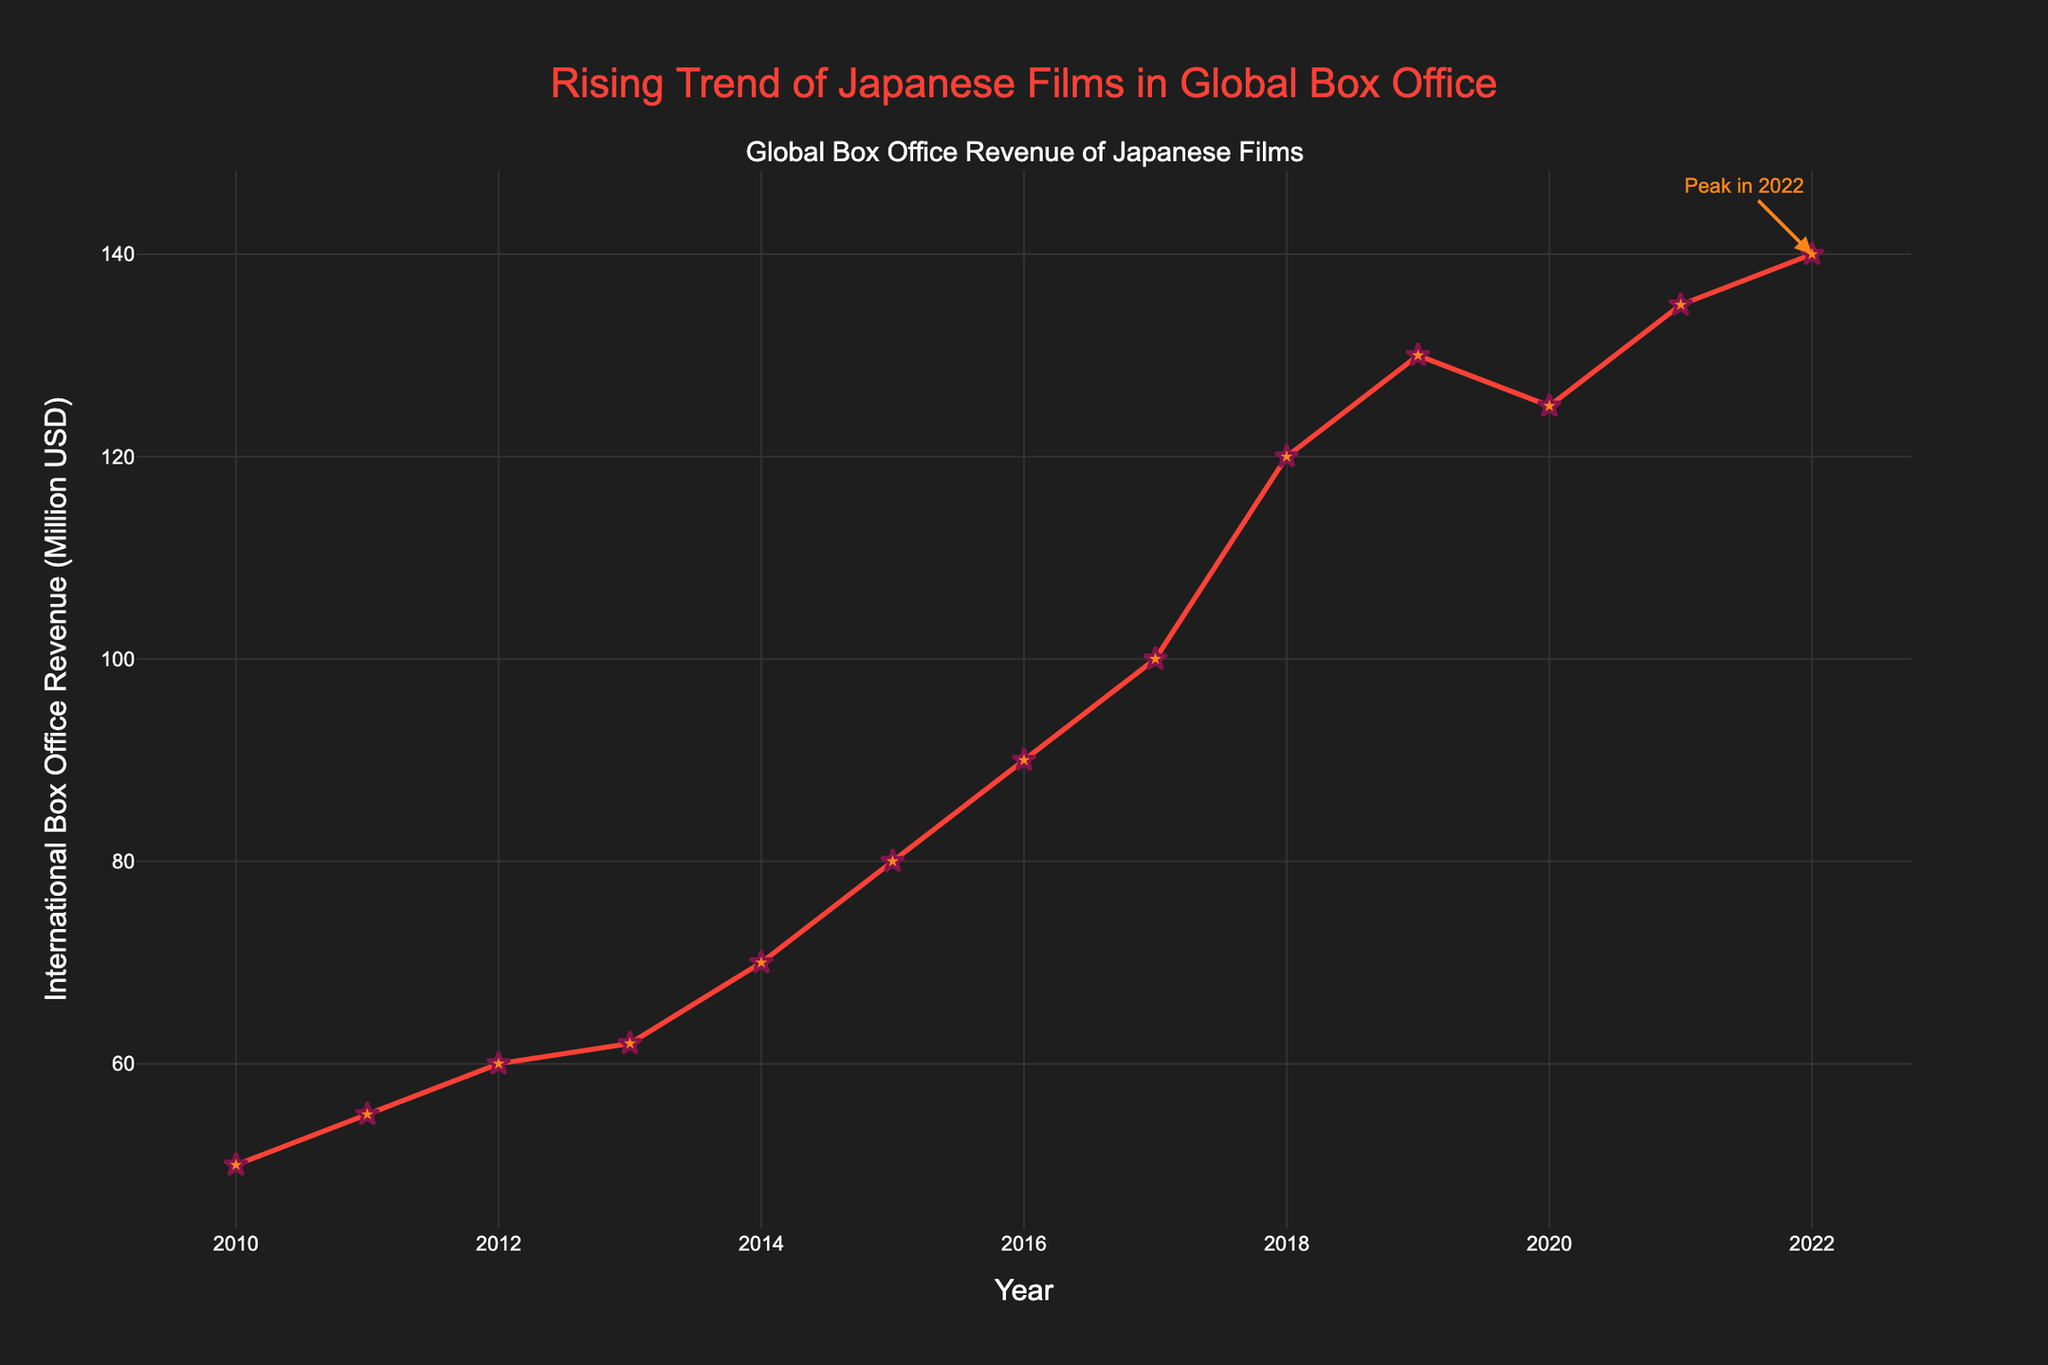What is the title of the figure? When looking at the top of the figure, we see the title "Rising Trend of Japanese Films in Global Box Office."
Answer: Rising Trend of Japanese Films in Global Box Office What trend can you observe in the international box office revenue of Japanese films from 2010 to 2022? Observing the line graph, there is a general upward trend in revenue from 2010 to 2022, although revenue dropped slightly in 2020.
Answer: Upward trend How much was the international box office revenue for Japanese films in 2010? By looking at the data points on the y-axis corresponding to the year 2010, the revenue is 50 million USD.
Answer: 50 million USD Which year had the peak international box office revenue in this time period? Checking the annotations and the highest data point in the plot, the peak year is marked as 2022 with 140 million USD.
Answer: 2022 What was the difference in revenue between the years 2019 and 2020? From the plot, the revenue in 2019 was 130 million USD and in 2020 it was 125 million USD. Therefore, the difference is 130 - 125 = 5 million USD.
Answer: 5 million USD What is the average annual revenue growth from 2010 to 2022? First, sum the yearly revenues from 2010 to 2022: (50 + 55 + 60 + 62 + 70 + 80 + 90 + 100 + 120 + 130 + 125 + 135 + 140) = 1217 million USD. There are 13 years. Therefore, the average annual revenue is 1217 / 13 ≈ 93.62 million USD.
Answer: 93.62 million USD Compare the revenue of 2014 and 2022. By how much did it increase? In 2014, the revenue was 70 million USD, and in 2022, it was 140 million USD. The increase is 140 - 70 = 70 million USD.
Answer: 70 million USD Which years had the same increase in revenue when compared to the previous year? From the timeline: 2011-2012 saw an increase of 5, and 2021-2022 saw an increase of 5. Both years 2012 and 2022 had the same increase of 5 million USD compared to the previous year.
Answer: 2012, 2022 